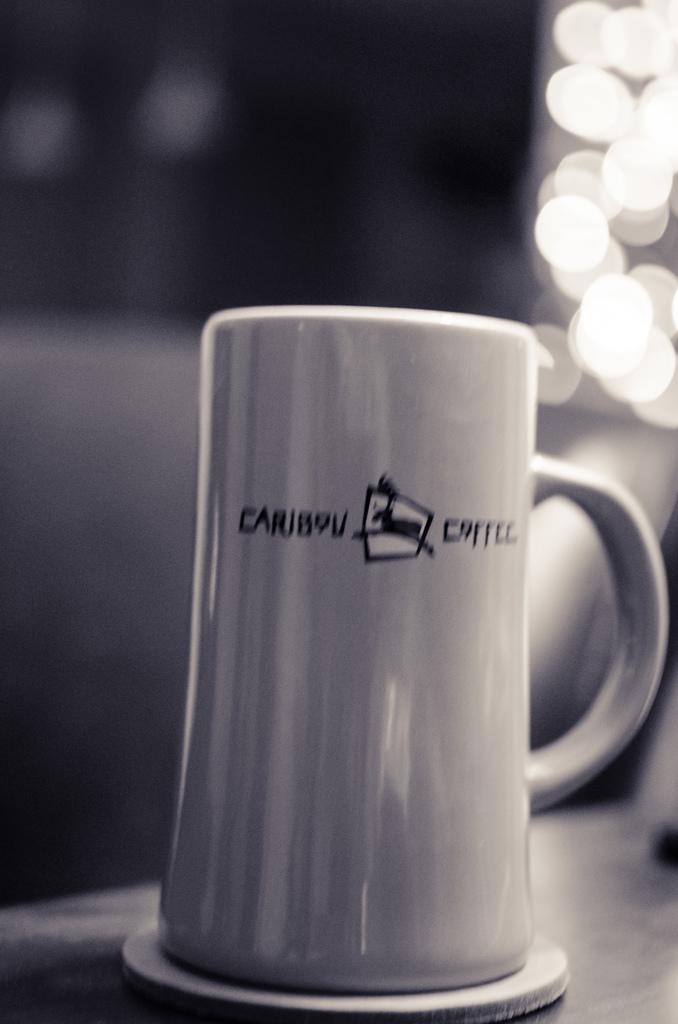<image>
Share a concise interpretation of the image provided. A Caribou Coffee brand mug sits on a coaster. 